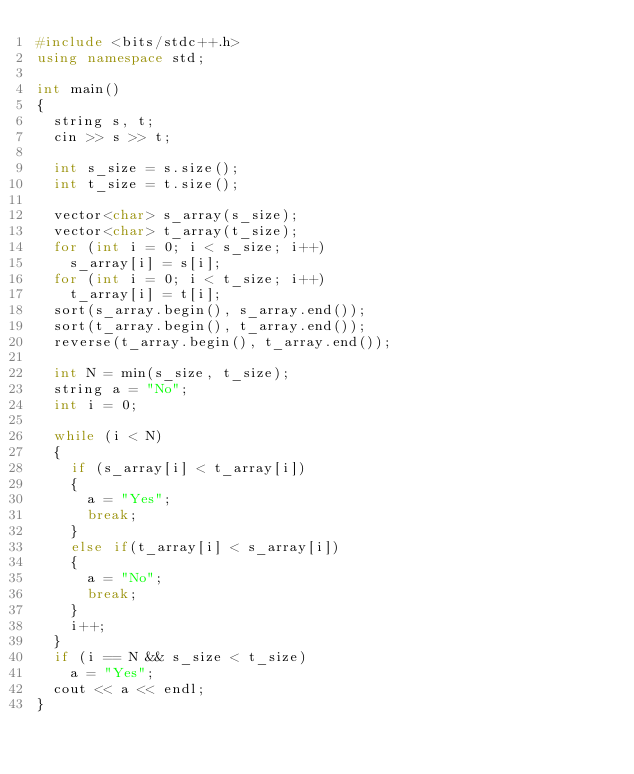Convert code to text. <code><loc_0><loc_0><loc_500><loc_500><_C++_>#include <bits/stdc++.h>
using namespace std;

int main()
{
  string s, t;
  cin >> s >> t;

  int s_size = s.size();
  int t_size = t.size();

  vector<char> s_array(s_size);
  vector<char> t_array(t_size);
  for (int i = 0; i < s_size; i++)
    s_array[i] = s[i];
  for (int i = 0; i < t_size; i++)
    t_array[i] = t[i];
  sort(s_array.begin(), s_array.end());
  sort(t_array.begin(), t_array.end());
  reverse(t_array.begin(), t_array.end());

  int N = min(s_size, t_size);
  string a = "No";
  int i = 0;

  while (i < N)
  {
    if (s_array[i] < t_array[i])
    {
      a = "Yes";
      break;
    }
    else if(t_array[i] < s_array[i])
    {
      a = "No";
      break;
    }
    i++;
  }
  if (i == N && s_size < t_size)
    a = "Yes";
  cout << a << endl;
}</code> 